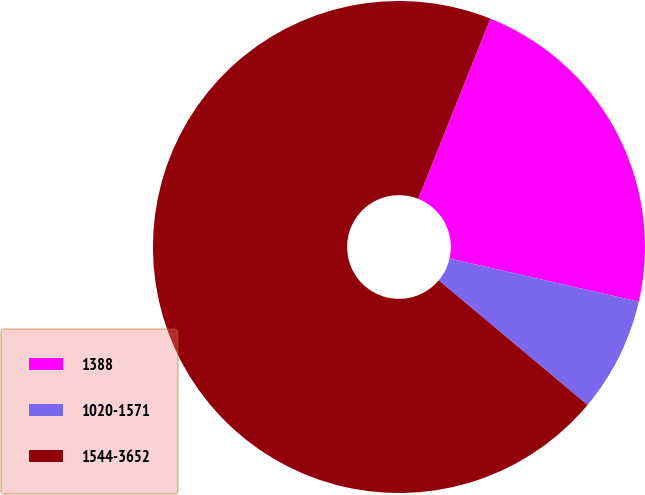Convert chart. <chart><loc_0><loc_0><loc_500><loc_500><pie_chart><fcel>1388<fcel>1020-1571<fcel>1544-3652<nl><fcel>22.51%<fcel>7.53%<fcel>69.96%<nl></chart> 